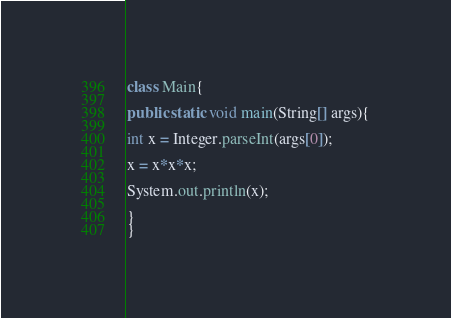<code> <loc_0><loc_0><loc_500><loc_500><_Java_>class Main{

public static void main(String[] args){

int x = Integer.parseInt(args[0]);

x = x*x*x;

System.out.println(x);

}
}</code> 